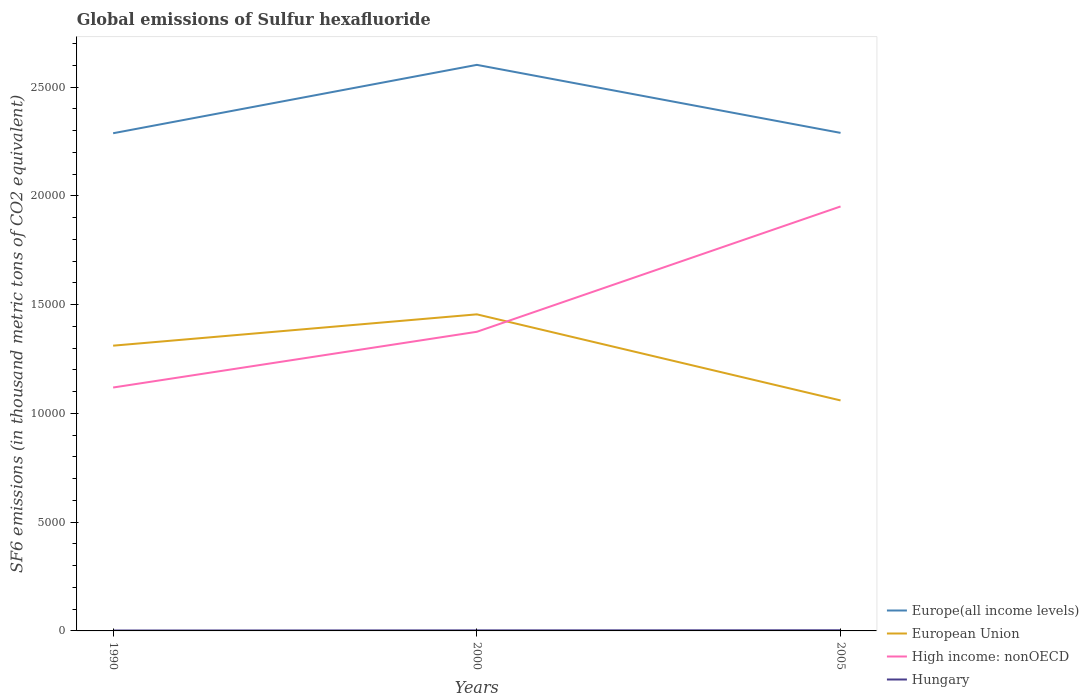Does the line corresponding to European Union intersect with the line corresponding to Europe(all income levels)?
Give a very brief answer. No. Is the number of lines equal to the number of legend labels?
Provide a short and direct response. Yes. Across all years, what is the maximum global emissions of Sulfur hexafluoride in Hungary?
Provide a succinct answer. 18.6. In which year was the global emissions of Sulfur hexafluoride in Hungary maximum?
Keep it short and to the point. 1990. What is the total global emissions of Sulfur hexafluoride in Hungary in the graph?
Your response must be concise. -6.6. What is the difference between the highest and the second highest global emissions of Sulfur hexafluoride in European Union?
Keep it short and to the point. 3958.08. Is the global emissions of Sulfur hexafluoride in Europe(all income levels) strictly greater than the global emissions of Sulfur hexafluoride in European Union over the years?
Offer a very short reply. No. How many years are there in the graph?
Offer a very short reply. 3. What is the difference between two consecutive major ticks on the Y-axis?
Your response must be concise. 5000. Are the values on the major ticks of Y-axis written in scientific E-notation?
Your answer should be compact. No. Does the graph contain any zero values?
Your answer should be very brief. No. Where does the legend appear in the graph?
Your answer should be compact. Bottom right. How are the legend labels stacked?
Your response must be concise. Vertical. What is the title of the graph?
Keep it short and to the point. Global emissions of Sulfur hexafluoride. Does "Algeria" appear as one of the legend labels in the graph?
Ensure brevity in your answer.  No. What is the label or title of the Y-axis?
Provide a succinct answer. SF6 emissions (in thousand metric tons of CO2 equivalent). What is the SF6 emissions (in thousand metric tons of CO2 equivalent) in Europe(all income levels) in 1990?
Ensure brevity in your answer.  2.29e+04. What is the SF6 emissions (in thousand metric tons of CO2 equivalent) of European Union in 1990?
Your answer should be very brief. 1.31e+04. What is the SF6 emissions (in thousand metric tons of CO2 equivalent) of High income: nonOECD in 1990?
Offer a terse response. 1.12e+04. What is the SF6 emissions (in thousand metric tons of CO2 equivalent) of Hungary in 1990?
Your response must be concise. 18.6. What is the SF6 emissions (in thousand metric tons of CO2 equivalent) of Europe(all income levels) in 2000?
Your answer should be very brief. 2.60e+04. What is the SF6 emissions (in thousand metric tons of CO2 equivalent) in European Union in 2000?
Offer a very short reply. 1.46e+04. What is the SF6 emissions (in thousand metric tons of CO2 equivalent) of High income: nonOECD in 2000?
Give a very brief answer. 1.38e+04. What is the SF6 emissions (in thousand metric tons of CO2 equivalent) of Hungary in 2000?
Give a very brief answer. 25.2. What is the SF6 emissions (in thousand metric tons of CO2 equivalent) of Europe(all income levels) in 2005?
Offer a terse response. 2.29e+04. What is the SF6 emissions (in thousand metric tons of CO2 equivalent) in European Union in 2005?
Make the answer very short. 1.06e+04. What is the SF6 emissions (in thousand metric tons of CO2 equivalent) of High income: nonOECD in 2005?
Provide a short and direct response. 1.95e+04. Across all years, what is the maximum SF6 emissions (in thousand metric tons of CO2 equivalent) of Europe(all income levels)?
Keep it short and to the point. 2.60e+04. Across all years, what is the maximum SF6 emissions (in thousand metric tons of CO2 equivalent) in European Union?
Offer a very short reply. 1.46e+04. Across all years, what is the maximum SF6 emissions (in thousand metric tons of CO2 equivalent) in High income: nonOECD?
Provide a succinct answer. 1.95e+04. Across all years, what is the minimum SF6 emissions (in thousand metric tons of CO2 equivalent) of Europe(all income levels)?
Your answer should be compact. 2.29e+04. Across all years, what is the minimum SF6 emissions (in thousand metric tons of CO2 equivalent) of European Union?
Your answer should be very brief. 1.06e+04. Across all years, what is the minimum SF6 emissions (in thousand metric tons of CO2 equivalent) in High income: nonOECD?
Provide a succinct answer. 1.12e+04. What is the total SF6 emissions (in thousand metric tons of CO2 equivalent) of Europe(all income levels) in the graph?
Keep it short and to the point. 7.18e+04. What is the total SF6 emissions (in thousand metric tons of CO2 equivalent) of European Union in the graph?
Your answer should be very brief. 3.83e+04. What is the total SF6 emissions (in thousand metric tons of CO2 equivalent) in High income: nonOECD in the graph?
Give a very brief answer. 4.45e+04. What is the total SF6 emissions (in thousand metric tons of CO2 equivalent) of Hungary in the graph?
Offer a very short reply. 73.8. What is the difference between the SF6 emissions (in thousand metric tons of CO2 equivalent) of Europe(all income levels) in 1990 and that in 2000?
Make the answer very short. -3144.4. What is the difference between the SF6 emissions (in thousand metric tons of CO2 equivalent) in European Union in 1990 and that in 2000?
Your response must be concise. -1440.2. What is the difference between the SF6 emissions (in thousand metric tons of CO2 equivalent) in High income: nonOECD in 1990 and that in 2000?
Make the answer very short. -2562.3. What is the difference between the SF6 emissions (in thousand metric tons of CO2 equivalent) of Hungary in 1990 and that in 2000?
Provide a short and direct response. -6.6. What is the difference between the SF6 emissions (in thousand metric tons of CO2 equivalent) of Europe(all income levels) in 1990 and that in 2005?
Give a very brief answer. -16.51. What is the difference between the SF6 emissions (in thousand metric tons of CO2 equivalent) of European Union in 1990 and that in 2005?
Your answer should be very brief. 2517.88. What is the difference between the SF6 emissions (in thousand metric tons of CO2 equivalent) in High income: nonOECD in 1990 and that in 2005?
Offer a very short reply. -8325.44. What is the difference between the SF6 emissions (in thousand metric tons of CO2 equivalent) of Hungary in 1990 and that in 2005?
Provide a succinct answer. -11.4. What is the difference between the SF6 emissions (in thousand metric tons of CO2 equivalent) of Europe(all income levels) in 2000 and that in 2005?
Make the answer very short. 3127.89. What is the difference between the SF6 emissions (in thousand metric tons of CO2 equivalent) of European Union in 2000 and that in 2005?
Your answer should be very brief. 3958.08. What is the difference between the SF6 emissions (in thousand metric tons of CO2 equivalent) of High income: nonOECD in 2000 and that in 2005?
Your answer should be very brief. -5763.14. What is the difference between the SF6 emissions (in thousand metric tons of CO2 equivalent) of Europe(all income levels) in 1990 and the SF6 emissions (in thousand metric tons of CO2 equivalent) of European Union in 2000?
Provide a short and direct response. 8327.6. What is the difference between the SF6 emissions (in thousand metric tons of CO2 equivalent) of Europe(all income levels) in 1990 and the SF6 emissions (in thousand metric tons of CO2 equivalent) of High income: nonOECD in 2000?
Make the answer very short. 9129.8. What is the difference between the SF6 emissions (in thousand metric tons of CO2 equivalent) in Europe(all income levels) in 1990 and the SF6 emissions (in thousand metric tons of CO2 equivalent) in Hungary in 2000?
Your answer should be very brief. 2.29e+04. What is the difference between the SF6 emissions (in thousand metric tons of CO2 equivalent) of European Union in 1990 and the SF6 emissions (in thousand metric tons of CO2 equivalent) of High income: nonOECD in 2000?
Offer a terse response. -638. What is the difference between the SF6 emissions (in thousand metric tons of CO2 equivalent) of European Union in 1990 and the SF6 emissions (in thousand metric tons of CO2 equivalent) of Hungary in 2000?
Your response must be concise. 1.31e+04. What is the difference between the SF6 emissions (in thousand metric tons of CO2 equivalent) in High income: nonOECD in 1990 and the SF6 emissions (in thousand metric tons of CO2 equivalent) in Hungary in 2000?
Provide a short and direct response. 1.12e+04. What is the difference between the SF6 emissions (in thousand metric tons of CO2 equivalent) of Europe(all income levels) in 1990 and the SF6 emissions (in thousand metric tons of CO2 equivalent) of European Union in 2005?
Provide a succinct answer. 1.23e+04. What is the difference between the SF6 emissions (in thousand metric tons of CO2 equivalent) of Europe(all income levels) in 1990 and the SF6 emissions (in thousand metric tons of CO2 equivalent) of High income: nonOECD in 2005?
Provide a succinct answer. 3366.66. What is the difference between the SF6 emissions (in thousand metric tons of CO2 equivalent) of Europe(all income levels) in 1990 and the SF6 emissions (in thousand metric tons of CO2 equivalent) of Hungary in 2005?
Your response must be concise. 2.29e+04. What is the difference between the SF6 emissions (in thousand metric tons of CO2 equivalent) in European Union in 1990 and the SF6 emissions (in thousand metric tons of CO2 equivalent) in High income: nonOECD in 2005?
Your answer should be compact. -6401.14. What is the difference between the SF6 emissions (in thousand metric tons of CO2 equivalent) of European Union in 1990 and the SF6 emissions (in thousand metric tons of CO2 equivalent) of Hungary in 2005?
Keep it short and to the point. 1.31e+04. What is the difference between the SF6 emissions (in thousand metric tons of CO2 equivalent) in High income: nonOECD in 1990 and the SF6 emissions (in thousand metric tons of CO2 equivalent) in Hungary in 2005?
Keep it short and to the point. 1.12e+04. What is the difference between the SF6 emissions (in thousand metric tons of CO2 equivalent) in Europe(all income levels) in 2000 and the SF6 emissions (in thousand metric tons of CO2 equivalent) in European Union in 2005?
Keep it short and to the point. 1.54e+04. What is the difference between the SF6 emissions (in thousand metric tons of CO2 equivalent) of Europe(all income levels) in 2000 and the SF6 emissions (in thousand metric tons of CO2 equivalent) of High income: nonOECD in 2005?
Offer a terse response. 6511.06. What is the difference between the SF6 emissions (in thousand metric tons of CO2 equivalent) of Europe(all income levels) in 2000 and the SF6 emissions (in thousand metric tons of CO2 equivalent) of Hungary in 2005?
Provide a succinct answer. 2.60e+04. What is the difference between the SF6 emissions (in thousand metric tons of CO2 equivalent) of European Union in 2000 and the SF6 emissions (in thousand metric tons of CO2 equivalent) of High income: nonOECD in 2005?
Your answer should be very brief. -4960.94. What is the difference between the SF6 emissions (in thousand metric tons of CO2 equivalent) in European Union in 2000 and the SF6 emissions (in thousand metric tons of CO2 equivalent) in Hungary in 2005?
Your answer should be very brief. 1.45e+04. What is the difference between the SF6 emissions (in thousand metric tons of CO2 equivalent) of High income: nonOECD in 2000 and the SF6 emissions (in thousand metric tons of CO2 equivalent) of Hungary in 2005?
Your response must be concise. 1.37e+04. What is the average SF6 emissions (in thousand metric tons of CO2 equivalent) of Europe(all income levels) per year?
Make the answer very short. 2.39e+04. What is the average SF6 emissions (in thousand metric tons of CO2 equivalent) in European Union per year?
Provide a short and direct response. 1.28e+04. What is the average SF6 emissions (in thousand metric tons of CO2 equivalent) in High income: nonOECD per year?
Offer a very short reply. 1.48e+04. What is the average SF6 emissions (in thousand metric tons of CO2 equivalent) of Hungary per year?
Give a very brief answer. 24.6. In the year 1990, what is the difference between the SF6 emissions (in thousand metric tons of CO2 equivalent) of Europe(all income levels) and SF6 emissions (in thousand metric tons of CO2 equivalent) of European Union?
Your response must be concise. 9767.8. In the year 1990, what is the difference between the SF6 emissions (in thousand metric tons of CO2 equivalent) in Europe(all income levels) and SF6 emissions (in thousand metric tons of CO2 equivalent) in High income: nonOECD?
Offer a terse response. 1.17e+04. In the year 1990, what is the difference between the SF6 emissions (in thousand metric tons of CO2 equivalent) of Europe(all income levels) and SF6 emissions (in thousand metric tons of CO2 equivalent) of Hungary?
Give a very brief answer. 2.29e+04. In the year 1990, what is the difference between the SF6 emissions (in thousand metric tons of CO2 equivalent) in European Union and SF6 emissions (in thousand metric tons of CO2 equivalent) in High income: nonOECD?
Offer a terse response. 1924.3. In the year 1990, what is the difference between the SF6 emissions (in thousand metric tons of CO2 equivalent) in European Union and SF6 emissions (in thousand metric tons of CO2 equivalent) in Hungary?
Ensure brevity in your answer.  1.31e+04. In the year 1990, what is the difference between the SF6 emissions (in thousand metric tons of CO2 equivalent) of High income: nonOECD and SF6 emissions (in thousand metric tons of CO2 equivalent) of Hungary?
Your answer should be very brief. 1.12e+04. In the year 2000, what is the difference between the SF6 emissions (in thousand metric tons of CO2 equivalent) in Europe(all income levels) and SF6 emissions (in thousand metric tons of CO2 equivalent) in European Union?
Provide a succinct answer. 1.15e+04. In the year 2000, what is the difference between the SF6 emissions (in thousand metric tons of CO2 equivalent) in Europe(all income levels) and SF6 emissions (in thousand metric tons of CO2 equivalent) in High income: nonOECD?
Keep it short and to the point. 1.23e+04. In the year 2000, what is the difference between the SF6 emissions (in thousand metric tons of CO2 equivalent) of Europe(all income levels) and SF6 emissions (in thousand metric tons of CO2 equivalent) of Hungary?
Ensure brevity in your answer.  2.60e+04. In the year 2000, what is the difference between the SF6 emissions (in thousand metric tons of CO2 equivalent) in European Union and SF6 emissions (in thousand metric tons of CO2 equivalent) in High income: nonOECD?
Offer a terse response. 802.2. In the year 2000, what is the difference between the SF6 emissions (in thousand metric tons of CO2 equivalent) in European Union and SF6 emissions (in thousand metric tons of CO2 equivalent) in Hungary?
Offer a very short reply. 1.45e+04. In the year 2000, what is the difference between the SF6 emissions (in thousand metric tons of CO2 equivalent) in High income: nonOECD and SF6 emissions (in thousand metric tons of CO2 equivalent) in Hungary?
Your answer should be very brief. 1.37e+04. In the year 2005, what is the difference between the SF6 emissions (in thousand metric tons of CO2 equivalent) of Europe(all income levels) and SF6 emissions (in thousand metric tons of CO2 equivalent) of European Union?
Provide a succinct answer. 1.23e+04. In the year 2005, what is the difference between the SF6 emissions (in thousand metric tons of CO2 equivalent) of Europe(all income levels) and SF6 emissions (in thousand metric tons of CO2 equivalent) of High income: nonOECD?
Ensure brevity in your answer.  3383.17. In the year 2005, what is the difference between the SF6 emissions (in thousand metric tons of CO2 equivalent) in Europe(all income levels) and SF6 emissions (in thousand metric tons of CO2 equivalent) in Hungary?
Make the answer very short. 2.29e+04. In the year 2005, what is the difference between the SF6 emissions (in thousand metric tons of CO2 equivalent) in European Union and SF6 emissions (in thousand metric tons of CO2 equivalent) in High income: nonOECD?
Ensure brevity in your answer.  -8919.03. In the year 2005, what is the difference between the SF6 emissions (in thousand metric tons of CO2 equivalent) in European Union and SF6 emissions (in thousand metric tons of CO2 equivalent) in Hungary?
Provide a short and direct response. 1.06e+04. In the year 2005, what is the difference between the SF6 emissions (in thousand metric tons of CO2 equivalent) of High income: nonOECD and SF6 emissions (in thousand metric tons of CO2 equivalent) of Hungary?
Your answer should be compact. 1.95e+04. What is the ratio of the SF6 emissions (in thousand metric tons of CO2 equivalent) in Europe(all income levels) in 1990 to that in 2000?
Make the answer very short. 0.88. What is the ratio of the SF6 emissions (in thousand metric tons of CO2 equivalent) of European Union in 1990 to that in 2000?
Offer a terse response. 0.9. What is the ratio of the SF6 emissions (in thousand metric tons of CO2 equivalent) of High income: nonOECD in 1990 to that in 2000?
Ensure brevity in your answer.  0.81. What is the ratio of the SF6 emissions (in thousand metric tons of CO2 equivalent) in Hungary in 1990 to that in 2000?
Your response must be concise. 0.74. What is the ratio of the SF6 emissions (in thousand metric tons of CO2 equivalent) in European Union in 1990 to that in 2005?
Provide a short and direct response. 1.24. What is the ratio of the SF6 emissions (in thousand metric tons of CO2 equivalent) in High income: nonOECD in 1990 to that in 2005?
Your answer should be compact. 0.57. What is the ratio of the SF6 emissions (in thousand metric tons of CO2 equivalent) in Hungary in 1990 to that in 2005?
Make the answer very short. 0.62. What is the ratio of the SF6 emissions (in thousand metric tons of CO2 equivalent) of Europe(all income levels) in 2000 to that in 2005?
Make the answer very short. 1.14. What is the ratio of the SF6 emissions (in thousand metric tons of CO2 equivalent) in European Union in 2000 to that in 2005?
Ensure brevity in your answer.  1.37. What is the ratio of the SF6 emissions (in thousand metric tons of CO2 equivalent) of High income: nonOECD in 2000 to that in 2005?
Offer a very short reply. 0.7. What is the ratio of the SF6 emissions (in thousand metric tons of CO2 equivalent) in Hungary in 2000 to that in 2005?
Give a very brief answer. 0.84. What is the difference between the highest and the second highest SF6 emissions (in thousand metric tons of CO2 equivalent) of Europe(all income levels)?
Your response must be concise. 3127.89. What is the difference between the highest and the second highest SF6 emissions (in thousand metric tons of CO2 equivalent) of European Union?
Offer a very short reply. 1440.2. What is the difference between the highest and the second highest SF6 emissions (in thousand metric tons of CO2 equivalent) of High income: nonOECD?
Offer a terse response. 5763.14. What is the difference between the highest and the lowest SF6 emissions (in thousand metric tons of CO2 equivalent) of Europe(all income levels)?
Make the answer very short. 3144.4. What is the difference between the highest and the lowest SF6 emissions (in thousand metric tons of CO2 equivalent) in European Union?
Your answer should be very brief. 3958.08. What is the difference between the highest and the lowest SF6 emissions (in thousand metric tons of CO2 equivalent) in High income: nonOECD?
Offer a terse response. 8325.44. 